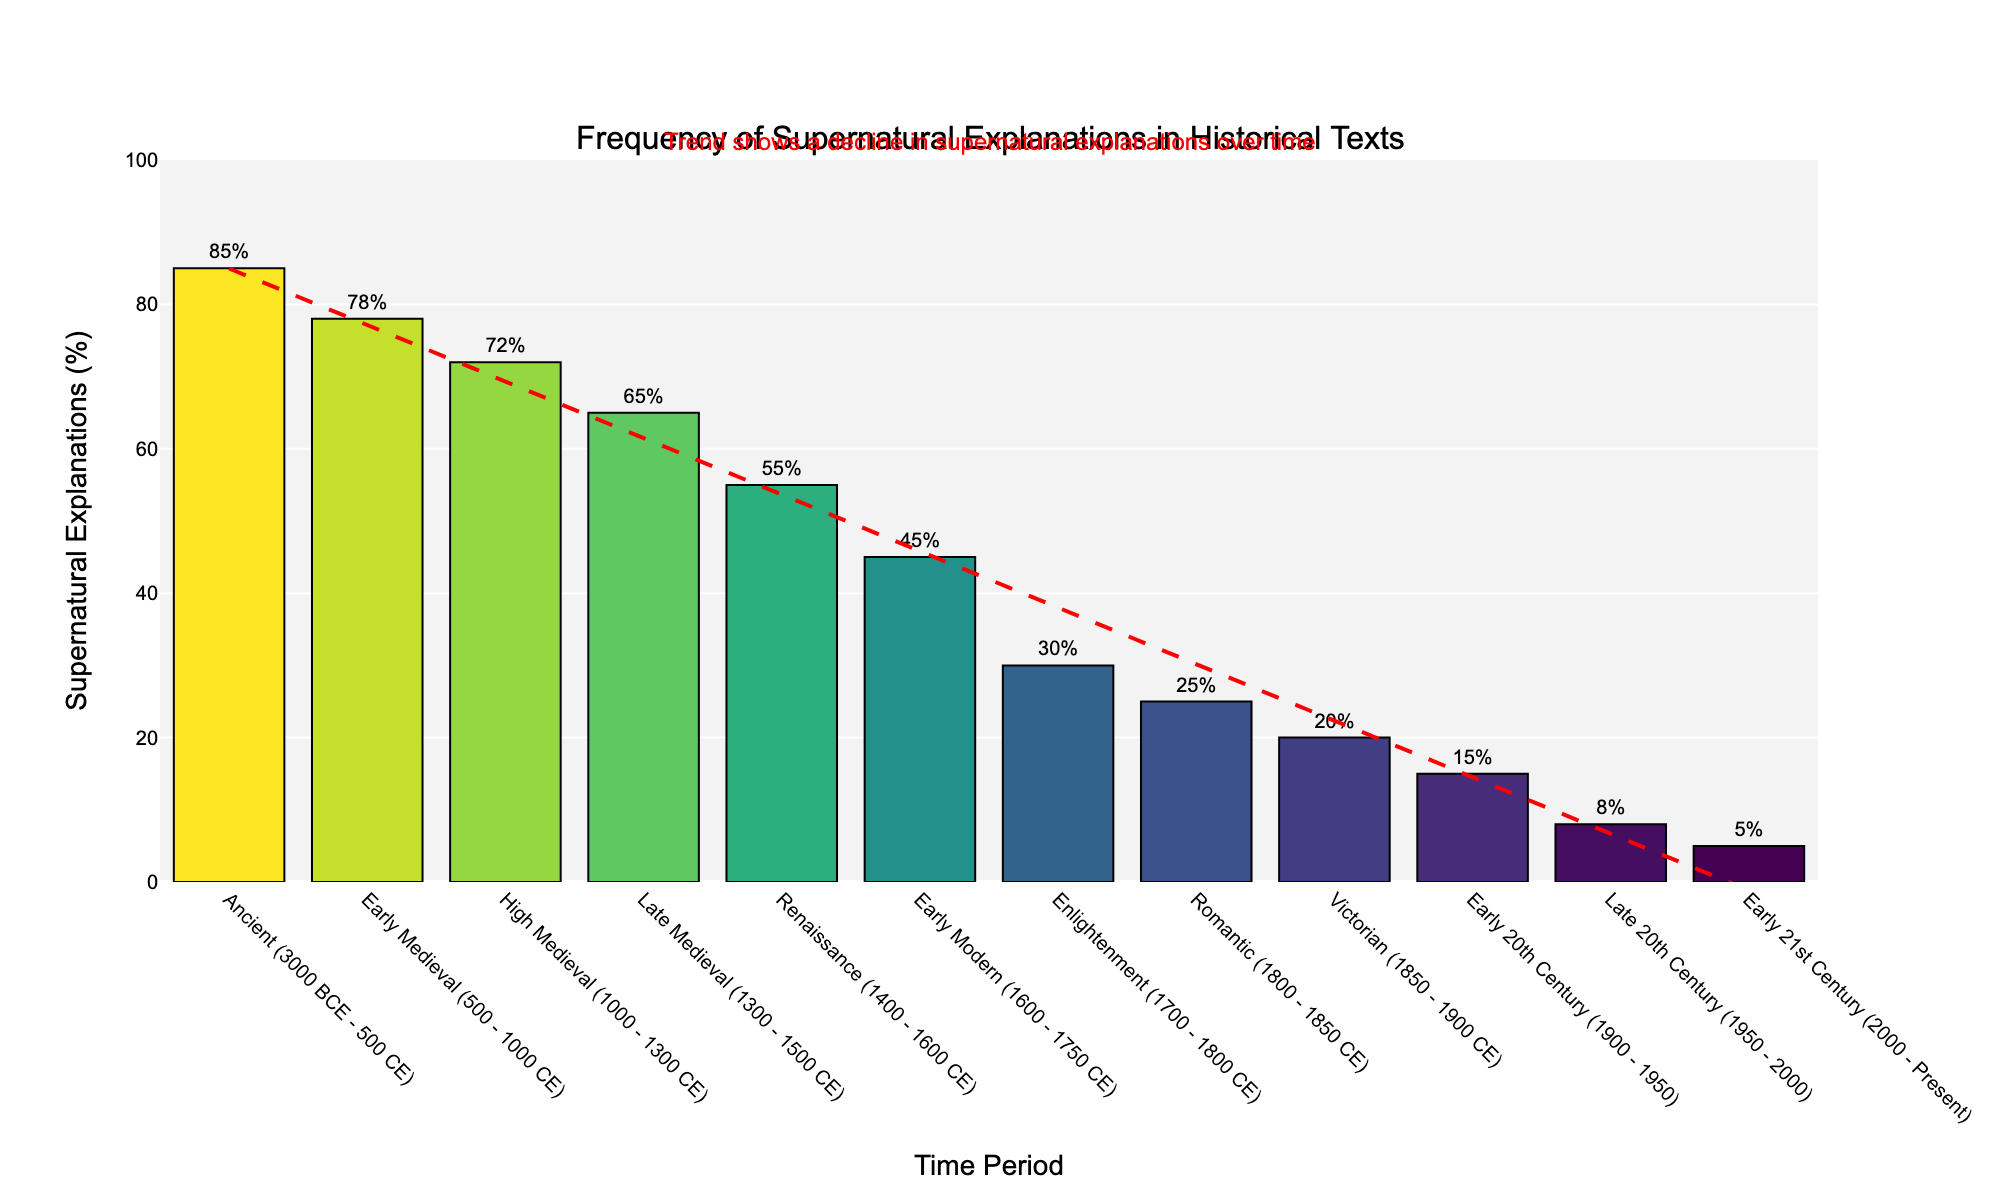What is the earliest time period where less than 10% of historical texts contain supernatural explanations? To identify the earliest time period with less than 10% of supernatural explanations, look for the first instance in the x-axis labels where the bar height is below the 10% mark. According to the chart, the "Late 20th Century (1950 - 2000)" period shows 8%, which is less than 10%.
Answer: Late 20th Century (1950 - 2000) How much did the percentage of supernatural explanations in historical texts decrease from the Ancient period to the Early Modern period? Subtract the percentage of the Early Modern period from the Ancient period. The Ancient period is 85%, and the Early Modern period is 45%. The difference is 85% - 45% = 40%.
Answer: 40% Which time period has the highest frequency of supernatural explanations in historical texts? Find the tallest bar in the chart and read its corresponding time period. The tallest bar belongs to the "Ancient (3000 BCE - 500 CE)" period, which is at 85%.
Answer: Ancient (3000 BCE - 500 CE) What is the average frequency of supernatural explanations across the Medieval periods (Early, High, Late)? Calculate the average by adding the percentages of the Early Medieval (78%), High Medieval (72%), and Late Medieval (65%) periods, then divide by 3. The sum is 78% + 72% + 65% = 215%. The average is 215% / 3 = 71.67%.
Answer: 71.67% Between which two consecutive time periods is the largest drop in the frequency of supernatural explanations observed? Determine the difference in percentages between each pair of consecutive time periods and identify the largest drop. The largest difference is between the Enlightenment (30%) and Romantic (25%) periods, with a difference of 45% - 30% = 15%.
Answer: Enlightenment to Romantic What trendline is visible in the chart, and what does it indicate about the frequency of supernatural explanations over time? Observe the red dashed line added as a trendline. It slopes downward from left to right, indicating a general decline in the frequency of supernatural explanations over time.
Answer: Decline over time How does the frequency of supernatural explanations during the Victorian period compare to the Renaissance period? Compare the bar heights or percentages of the Victorian (20%) and Renaissance (55%) periods. The Victorian period is significantly lower at 20% compared to 55% in the Renaissance.
Answer: Victorian period is lower By what percentage did supernatural explanations decline from the Early 20th Century to the Early 21st Century? Check the percentage for the Early 20th Century (15%) and the Early 21st Century (5%), then subtract the latter from the former. The difference is 15% - 5% = 10%.
Answer: 10% Is there any overlap between time periods in the chart, and how does it affect the interpretation of data? Notice the overlapping periods: Renaissance (1400 - 1600 CE) overlaps with Early Modern (1600 - 1750 CE), and Enlightenment (1700 - 1800 CE) overlaps with Early Modern (1600 - 1750 CE). These overlaps don't affect the vertical comparison of percentages but might complicate temporal narratives.
Answer: Yes, there is overlap 